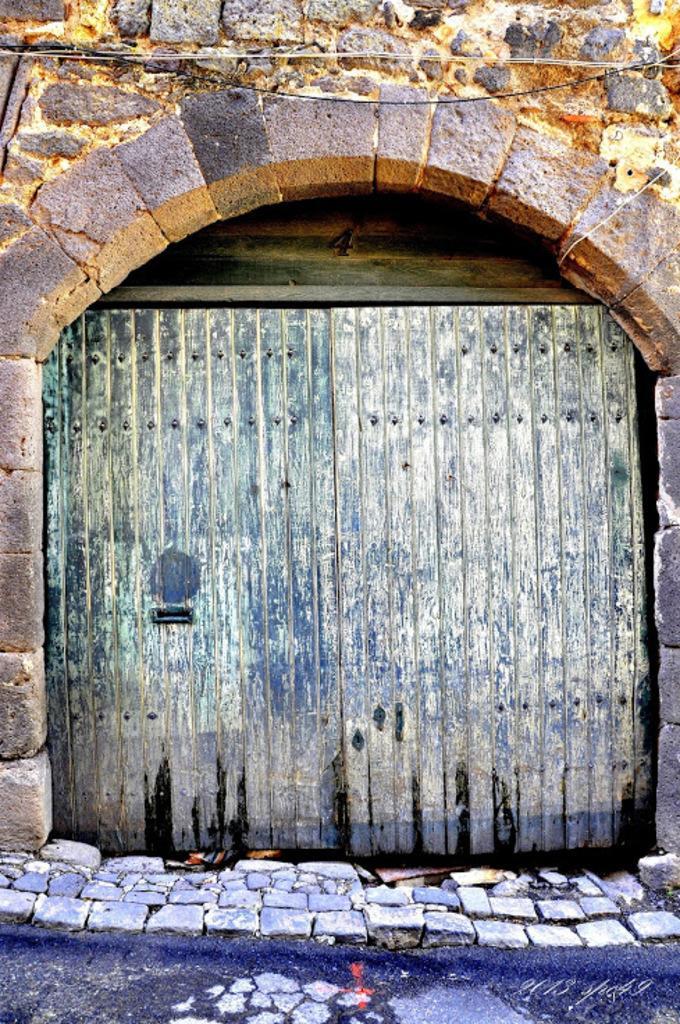Describe this image in one or two sentences. In front of the picture, we see an entrance door. At the bottom of the picture, we see the stones. In the background, we see a wall which is made up of stones. This might be a castle. 